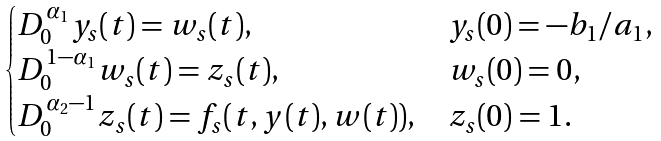<formula> <loc_0><loc_0><loc_500><loc_500>\begin{cases} D ^ { \alpha _ { 1 } } _ { 0 } y _ { s } ( t ) = w _ { s } ( t ) , & y _ { s } ( 0 ) = - b _ { 1 } / a _ { 1 } , \\ D ^ { 1 - \alpha _ { 1 } } _ { 0 } w _ { s } ( t ) = z _ { s } ( t ) , & w _ { s } ( 0 ) = 0 , \\ D ^ { \alpha _ { 2 } - 1 } _ { 0 } z _ { s } ( t ) = f _ { s } ( t , y ( t ) , w ( t ) ) , & z _ { s } ( 0 ) = 1 . \end{cases}</formula> 